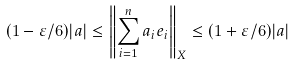<formula> <loc_0><loc_0><loc_500><loc_500>( 1 - \varepsilon / 6 ) | a | \leq \left \| \sum _ { i = 1 } ^ { n } a _ { i } e _ { i } \right \| _ { X } \leq ( 1 + \varepsilon / 6 ) | a |</formula> 